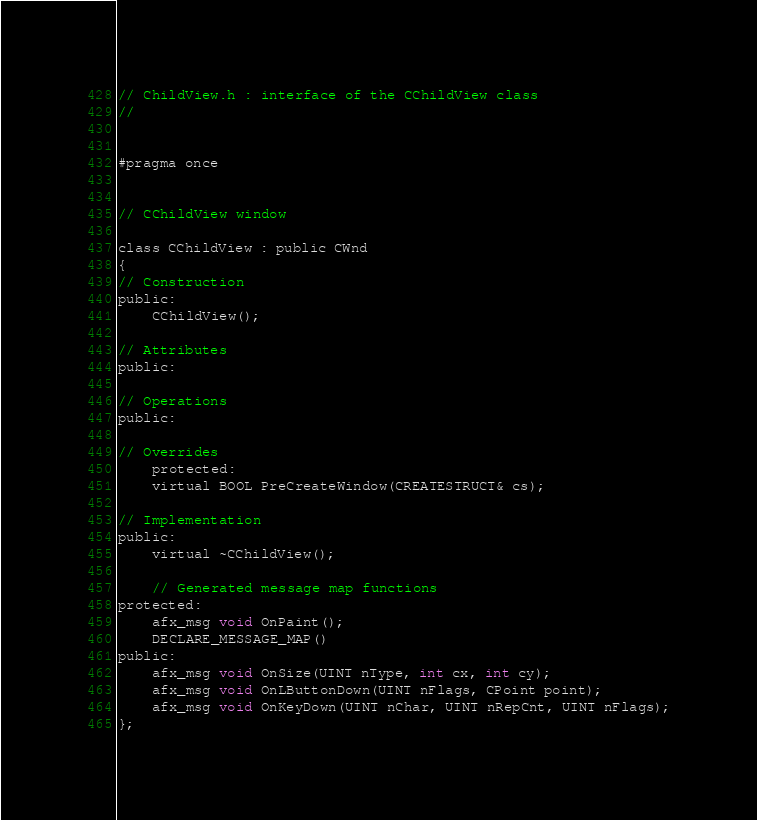Convert code to text. <code><loc_0><loc_0><loc_500><loc_500><_C_>// ChildView.h : interface of the CChildView class
//


#pragma once


// CChildView window

class CChildView : public CWnd
{
// Construction
public:
	CChildView();

// Attributes
public:

// Operations
public:

// Overrides
	protected:
	virtual BOOL PreCreateWindow(CREATESTRUCT& cs);

// Implementation
public:
	virtual ~CChildView();

	// Generated message map functions
protected:
	afx_msg void OnPaint();
	DECLARE_MESSAGE_MAP()
public:
	afx_msg void OnSize(UINT nType, int cx, int cy);
	afx_msg void OnLButtonDown(UINT nFlags, CPoint point);
	afx_msg void OnKeyDown(UINT nChar, UINT nRepCnt, UINT nFlags);
};

</code> 